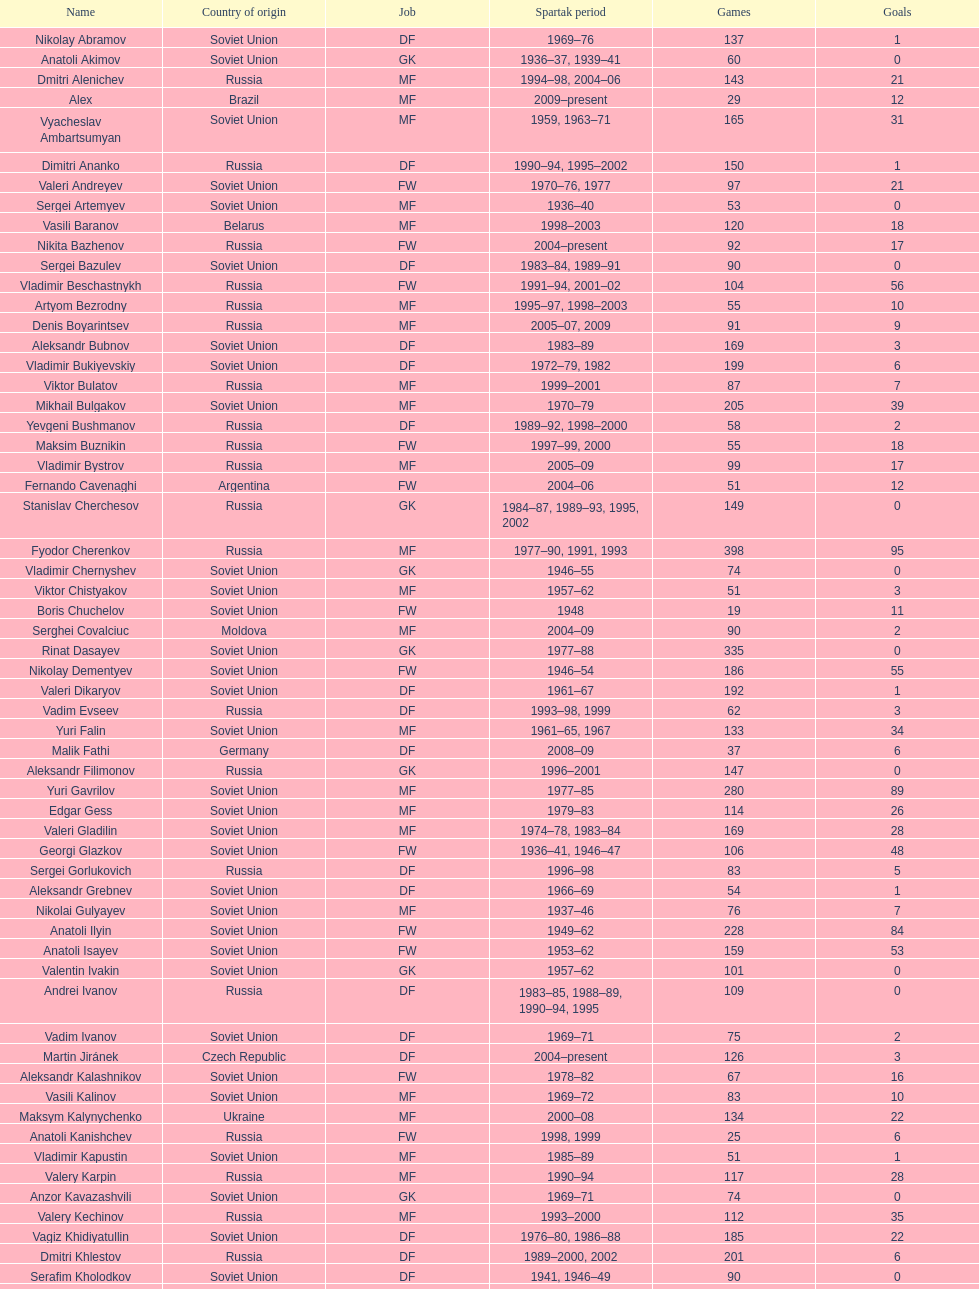Which player has the highest number of goals? Nikita Simonyan. 